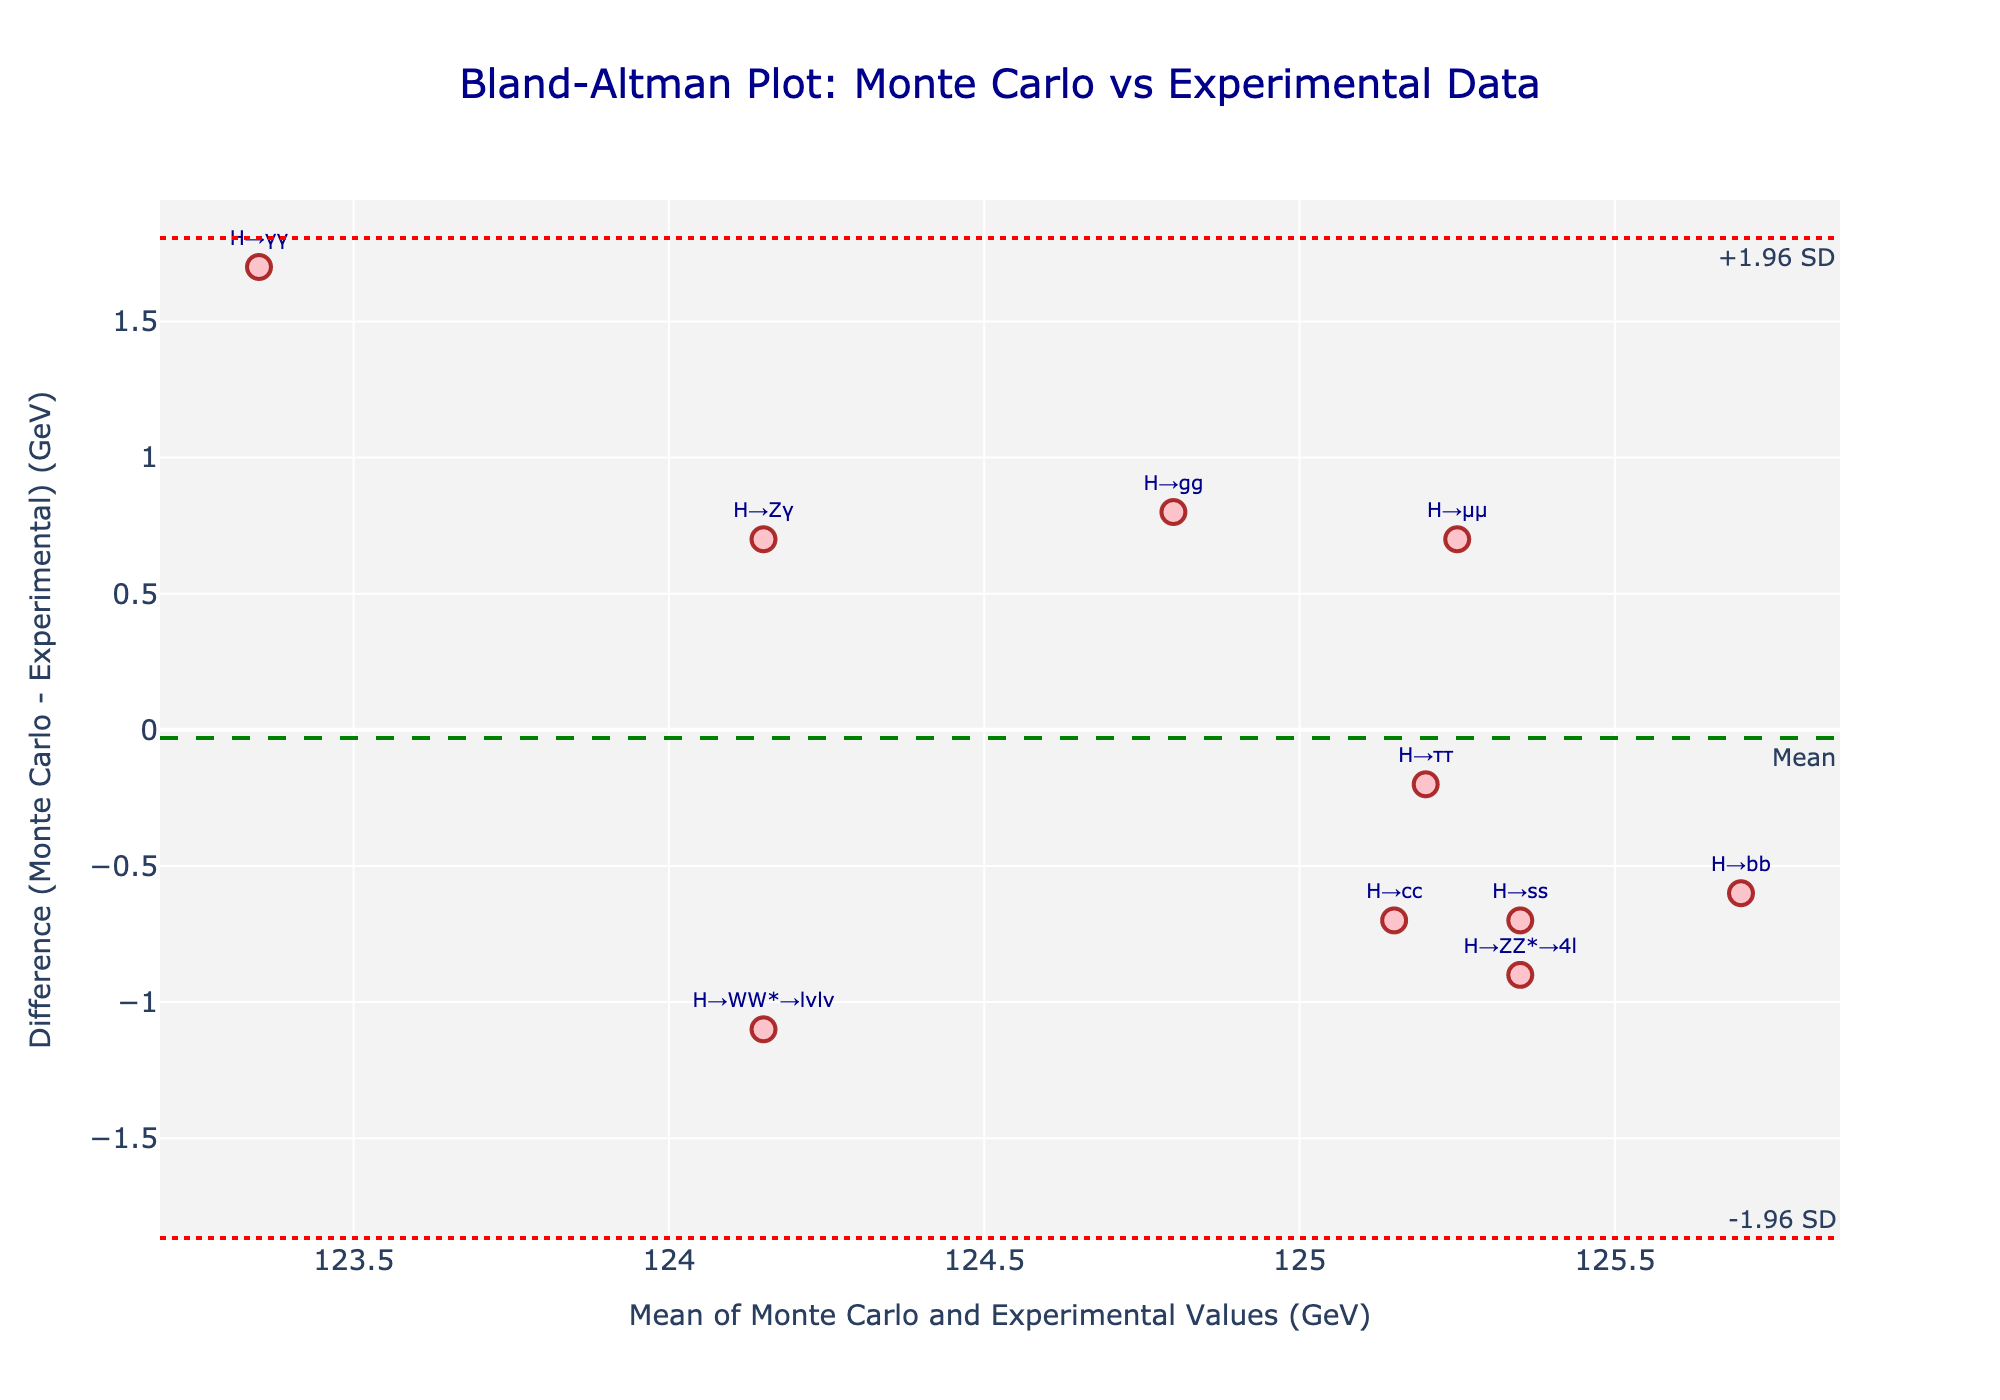what is the title of the plot? The title is a text element usually placed at the top of the plot, indicating its subject matter. In this plot, it reads "Bland-Altman Plot: Monte Carlo vs Experimental Data".
Answer: Bland-Altman Plot: Monte Carlo vs Experimental Data What is the range of the mean on the x-axis? The x-axis represents "Mean of Monte Carlo and Experimental Values (GeV)". By looking at the axis ticks, we can see it ranges approximately from 123 to 126 GeV.
Answer: 123 to 126 GeV What is the mean difference between the Monte Carlo and Experimental data? The mean difference is represented by a dashed green line in the plot. Its value is annotated near the line as "Mean". By reading this annotation, we find that the mean difference is approximately 0.08 GeV.
Answer: 0.08 GeV Which Higgs boson decay channel has the highest positive difference between Monte Carlo simulation and Experimental data? The difference is visually represented by the vertical distance from the x-axis. The point (H→γγ) with the largest positive y-value indicates the highest positive difference of 1.7 GeV.
Answer: H→γγ What is the standard deviation of the differences? The +1.96 SD and -1.96 SD lines are annotated in the plot, and the difference between these values and the mean difference gives us 1.96 times the standard deviation. By reading the values, the SD can be calculated as (1.96 SD Value - Mean Difference) / 1.96. If these lines are at approximately 1.8 and -1.7, the standard deviation is estimated as (1.8 - 0.08) / 1.96 or approximately 0.87 GeV.
Answer: 0.87 GeV How many decay channels have a negative difference? The points below the x-axis represent decay channels where the Monte Carlo value is less than the Experimental value. Counting these points, we find there are 5: (H→ZZ*→4l), (H→WW*→lνlν), (H→ττ), (H→bb), (H→cc), (H→ss).
Answer: 6 Which decay channel has the smallest absolute difference between Monte Carlo simulation and Experimental data? The smallest absolute difference is represented by the point closest to the x-axis (y=0). The decay channel closest to this line is (H→ττ) with a difference of -0.2 GeV.
Answer: H→ττ Is the difference for the decay channel H→gg positive or negative? The difference for H→gg is indicated by its position relative to the x-axis at the corresponding mean value. It is above the x-axis, indicating a positive difference.
Answer: Positive What is the average mean (x-axis values) for the decay channels H→γγ and H→μμ? To find the average mean of these two channels, sum their individual means and divide by 2. Mean for H→γγ is (122.5+124.2)/2 = 123.35, and for H→μμ is (124.9+125.6)/2 = 125.25. The average mean is (123.35 + 125.25) / 2 = 124.30 GeV.
Answer: 124.30 GeV 